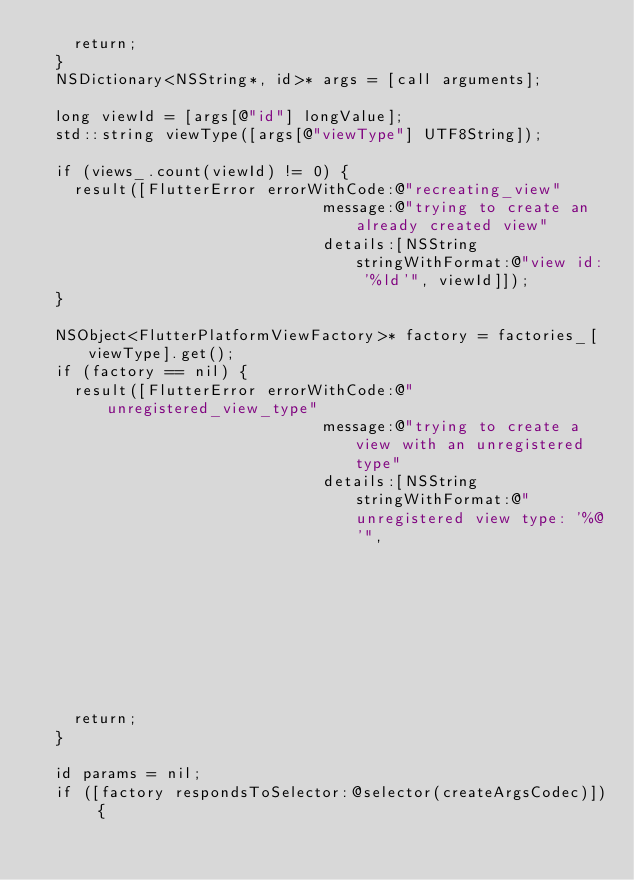Convert code to text. <code><loc_0><loc_0><loc_500><loc_500><_ObjectiveC_>    return;
  }
  NSDictionary<NSString*, id>* args = [call arguments];

  long viewId = [args[@"id"] longValue];
  std::string viewType([args[@"viewType"] UTF8String]);

  if (views_.count(viewId) != 0) {
    result([FlutterError errorWithCode:@"recreating_view"
                               message:@"trying to create an already created view"
                               details:[NSString stringWithFormat:@"view id: '%ld'", viewId]]);
  }

  NSObject<FlutterPlatformViewFactory>* factory = factories_[viewType].get();
  if (factory == nil) {
    result([FlutterError errorWithCode:@"unregistered_view_type"
                               message:@"trying to create a view with an unregistered type"
                               details:[NSString stringWithFormat:@"unregistered view type: '%@'",
                                                                  args[@"viewType"]]]);
    return;
  }

  id params = nil;
  if ([factory respondsToSelector:@selector(createArgsCodec)]) {</code> 